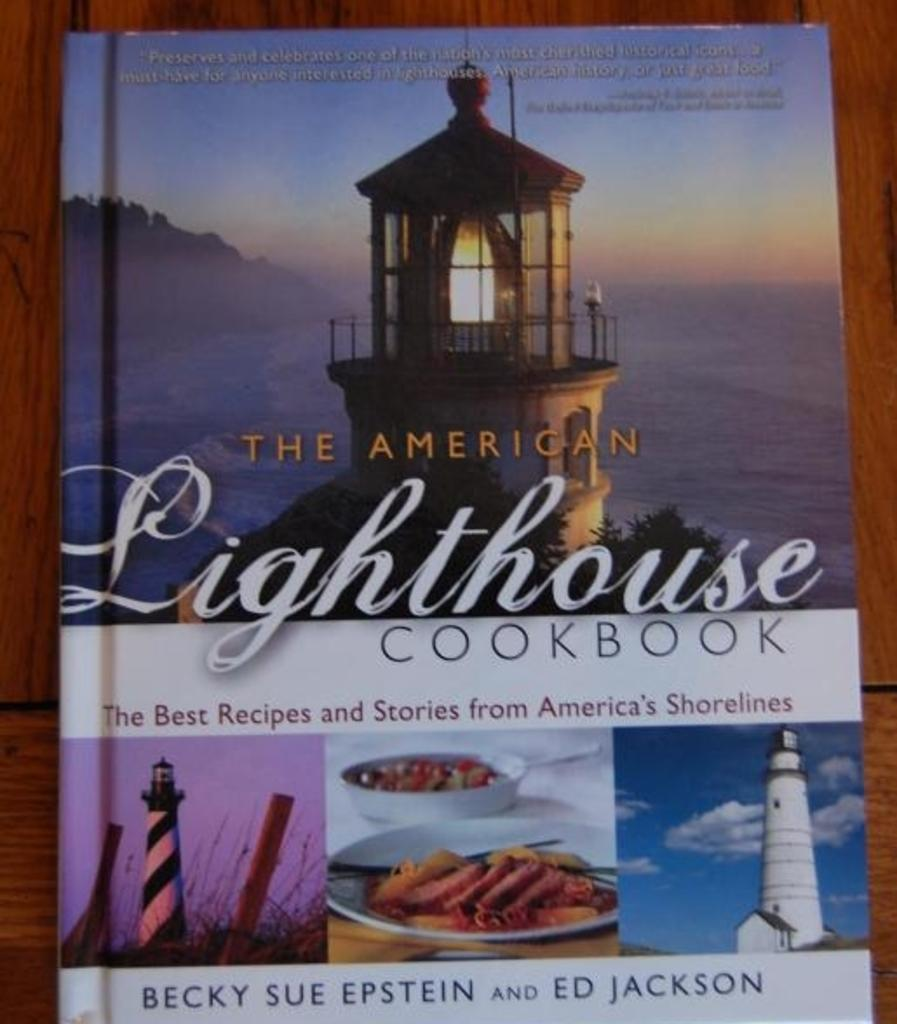<image>
Provide a brief description of the given image. A cookbook from America with the best receipes and stories from America. 